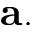<formula> <loc_0><loc_0><loc_500><loc_500>a .</formula> 